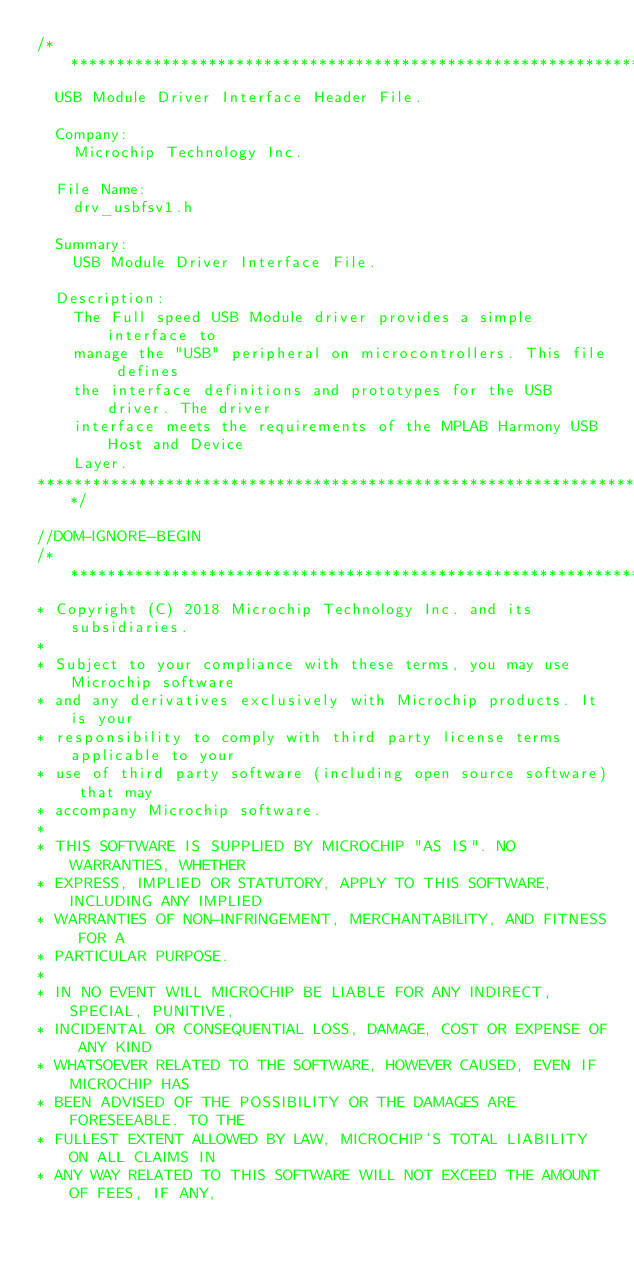<code> <loc_0><loc_0><loc_500><loc_500><_C_>/******************************************************************************
  USB Module Driver Interface Header File.

  Company:
    Microchip Technology Inc.
    
  File Name:
    drv_usbfsv1.h
	
  Summary:
    USB Module Driver Interface File.
	
  Description:
    The Full speed USB Module driver provides a simple interface to
    manage the "USB" peripheral on microcontrollers. This file defines
    the interface definitions and prototypes for the USB driver. The driver
    interface meets the requirements of the MPLAB Harmony USB Host and Device
    Layer.                                                  
*******************************************************************************/

//DOM-IGNORE-BEGIN
/*******************************************************************************
* Copyright (C) 2018 Microchip Technology Inc. and its subsidiaries.
*
* Subject to your compliance with these terms, you may use Microchip software
* and any derivatives exclusively with Microchip products. It is your
* responsibility to comply with third party license terms applicable to your
* use of third party software (including open source software) that may
* accompany Microchip software.
*
* THIS SOFTWARE IS SUPPLIED BY MICROCHIP "AS IS". NO WARRANTIES, WHETHER
* EXPRESS, IMPLIED OR STATUTORY, APPLY TO THIS SOFTWARE, INCLUDING ANY IMPLIED
* WARRANTIES OF NON-INFRINGEMENT, MERCHANTABILITY, AND FITNESS FOR A
* PARTICULAR PURPOSE.
*
* IN NO EVENT WILL MICROCHIP BE LIABLE FOR ANY INDIRECT, SPECIAL, PUNITIVE,
* INCIDENTAL OR CONSEQUENTIAL LOSS, DAMAGE, COST OR EXPENSE OF ANY KIND
* WHATSOEVER RELATED TO THE SOFTWARE, HOWEVER CAUSED, EVEN IF MICROCHIP HAS
* BEEN ADVISED OF THE POSSIBILITY OR THE DAMAGES ARE FORESEEABLE. TO THE
* FULLEST EXTENT ALLOWED BY LAW, MICROCHIP'S TOTAL LIABILITY ON ALL CLAIMS IN
* ANY WAY RELATED TO THIS SOFTWARE WILL NOT EXCEED THE AMOUNT OF FEES, IF ANY,</code> 